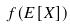<formula> <loc_0><loc_0><loc_500><loc_500>f ( E [ X ] )</formula> 